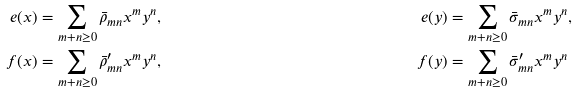<formula> <loc_0><loc_0><loc_500><loc_500>e ( x ) & = \sum _ { m + n \geq 0 } \bar { \rho } _ { m n } x ^ { m } y ^ { n } , & e ( y ) & = \sum _ { m + n \geq 0 } \bar { \sigma } _ { m n } x ^ { m } y ^ { n } , & \\ f ( x ) & = \sum _ { m + n \geq 0 } \bar { \rho } _ { m n } ^ { \prime } x ^ { m } y ^ { n } , & f ( y ) & = \sum _ { m + n \geq 0 } \bar { \sigma } _ { m n } ^ { \prime } x ^ { m } y ^ { n } &</formula> 